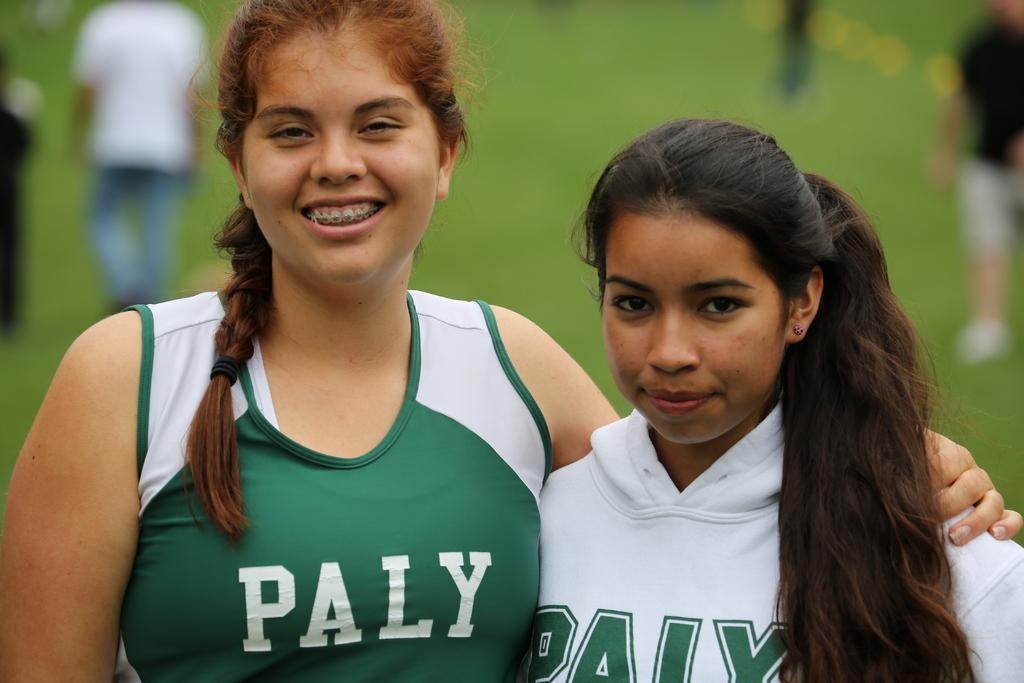How would you summarize this image in a sentence or two? In this image in the foreground there are two girls who are standing and smiling, and in the background there are some people who are walking and there is grass. 